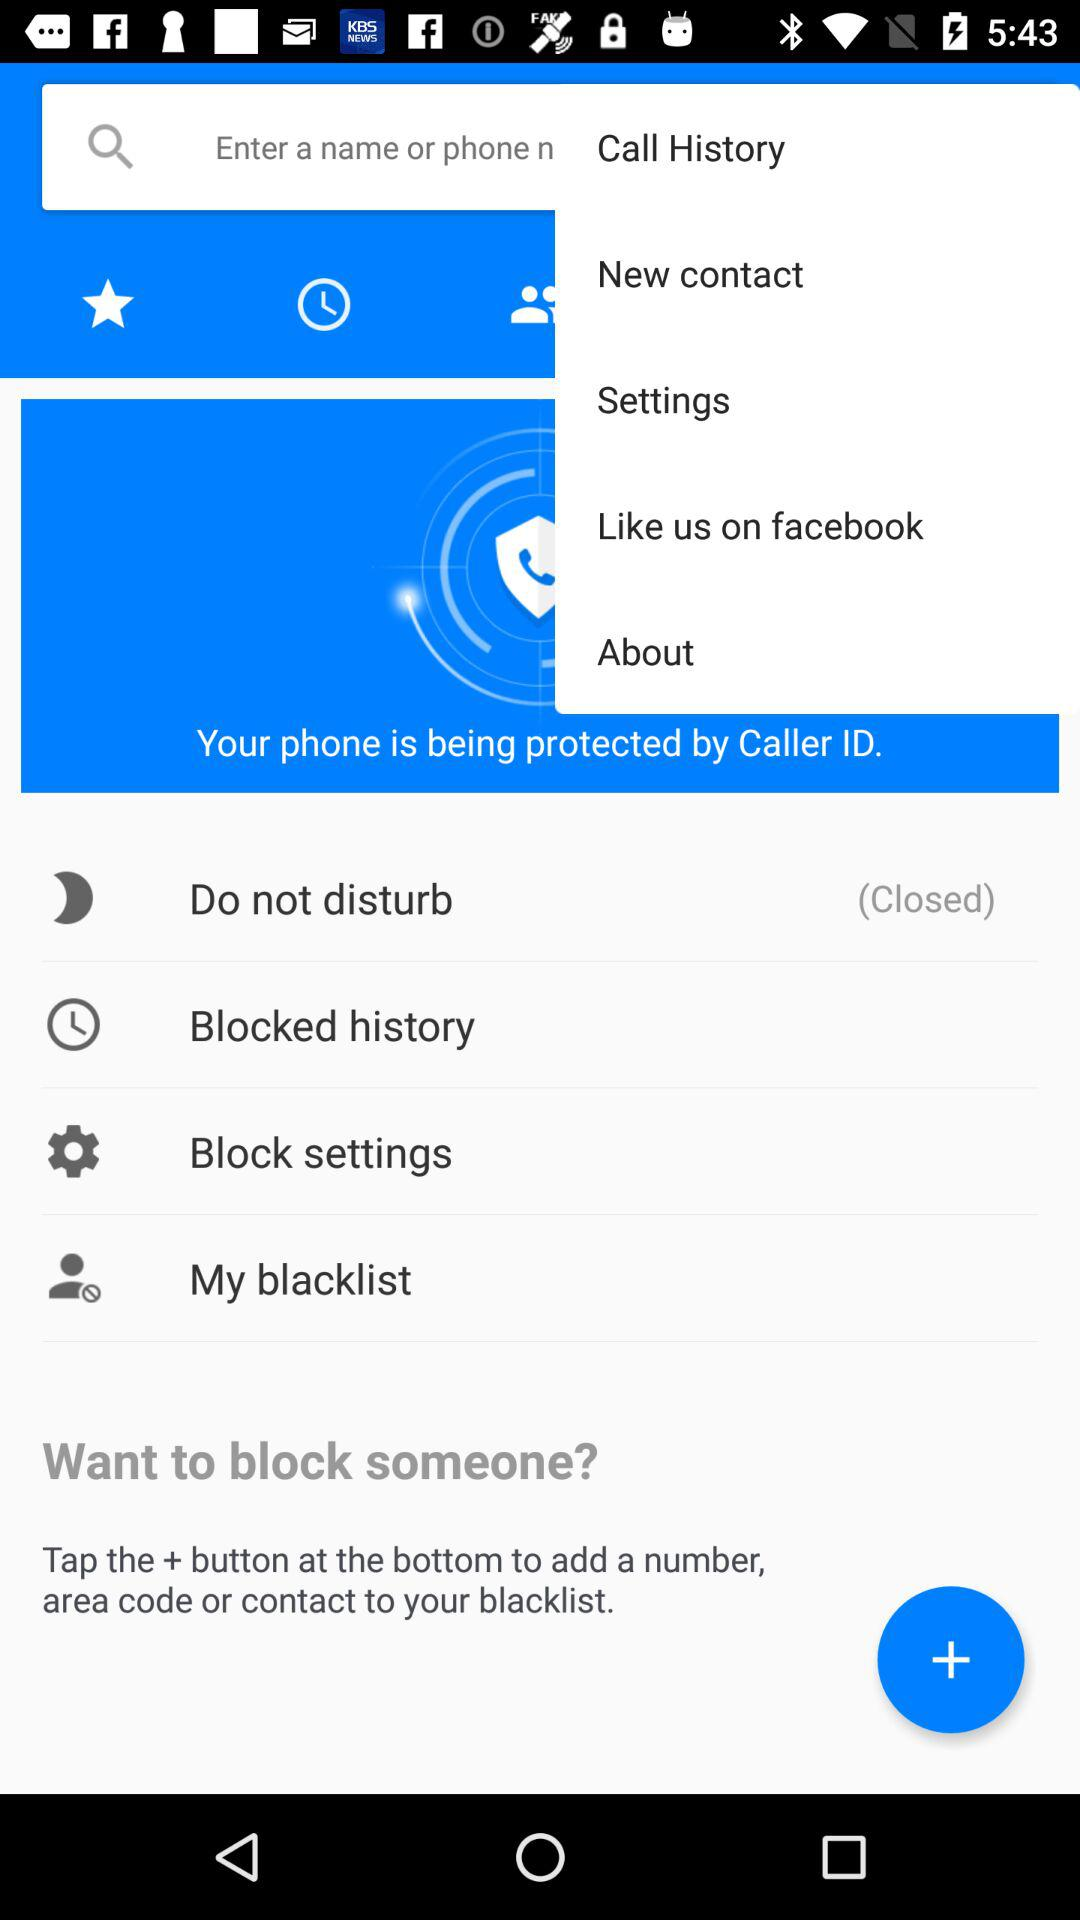The phone is protected by whom? The phone is protected by caller ID. 